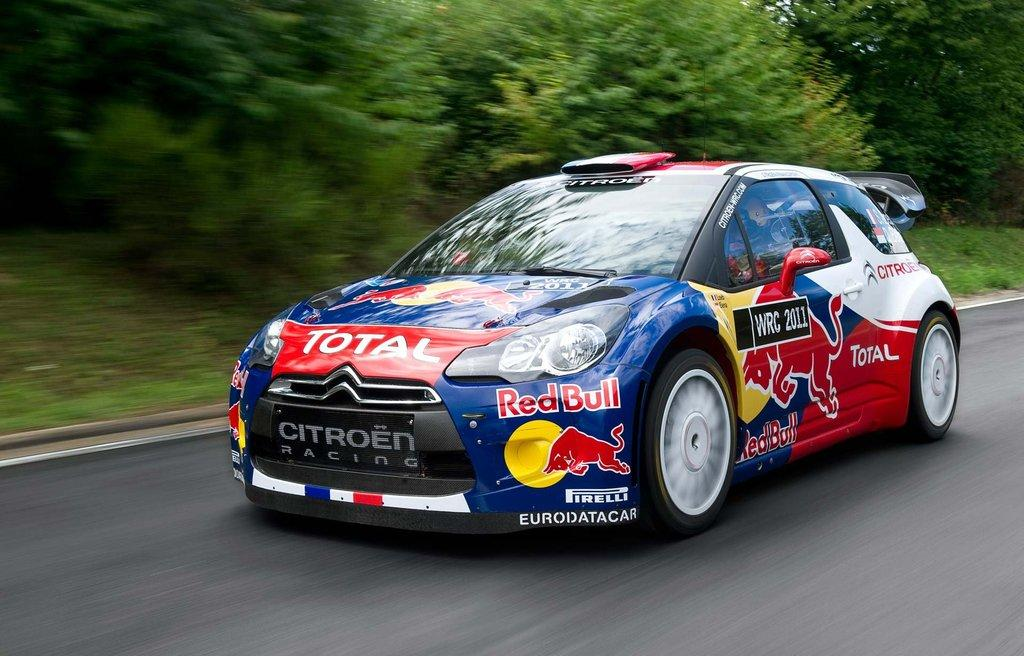What is the main subject of the picture? The main subject of the picture is a racing car. Where is the racing car located in the image? The racing car is on the road in the image. What can be seen in the background of the picture? There are trees visible in the background of the image. What type of gold vessel is visible on the racing car in the image? There is no gold vessel present on the racing car in the image. What color is the silver medal hanging from the rearview mirror of the racing car in the image? There is no rearview mirror or medal visible on the racing car in the image. 